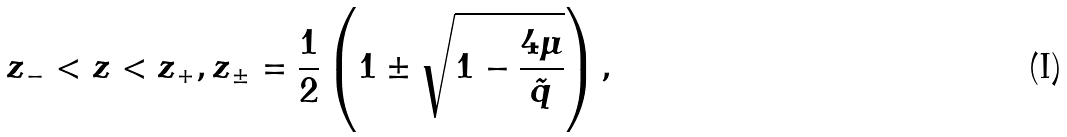<formula> <loc_0><loc_0><loc_500><loc_500>z _ { - } < z < z _ { + } , z _ { \pm } = \frac { 1 } { 2 } \left ( 1 \pm \sqrt { 1 - \frac { 4 \mu } { \tilde { q } } } \right ) ,</formula> 